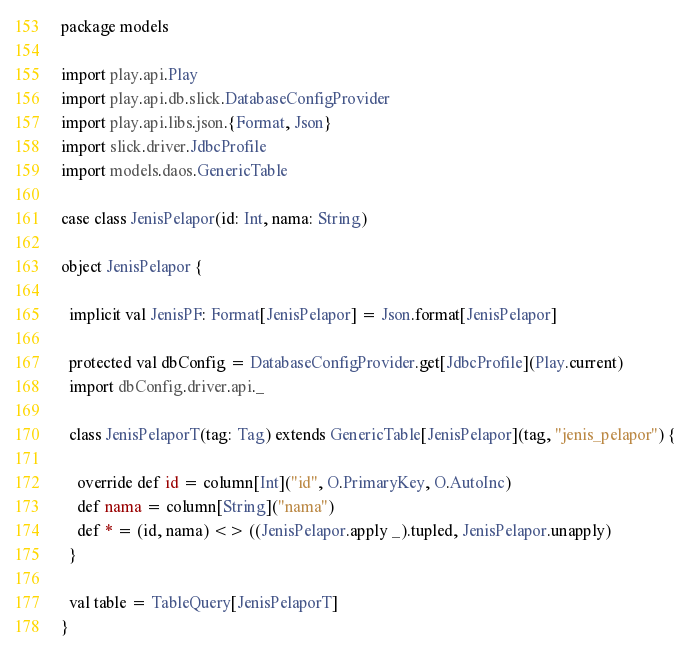<code> <loc_0><loc_0><loc_500><loc_500><_Scala_>package models

import play.api.Play
import play.api.db.slick.DatabaseConfigProvider
import play.api.libs.json.{Format, Json}
import slick.driver.JdbcProfile
import models.daos.GenericTable

case class JenisPelapor(id: Int, nama: String)

object JenisPelapor {

  implicit val JenisPF: Format[JenisPelapor] = Json.format[JenisPelapor]

  protected val dbConfig = DatabaseConfigProvider.get[JdbcProfile](Play.current)
  import dbConfig.driver.api._

  class JenisPelaporT(tag: Tag) extends GenericTable[JenisPelapor](tag, "jenis_pelapor") {

    override def id = column[Int]("id", O.PrimaryKey, O.AutoInc)
    def nama = column[String]("nama")
    def * = (id, nama) <> ((JenisPelapor.apply _).tupled, JenisPelapor.unapply)
  }
  
  val table = TableQuery[JenisPelaporT]
}
</code> 